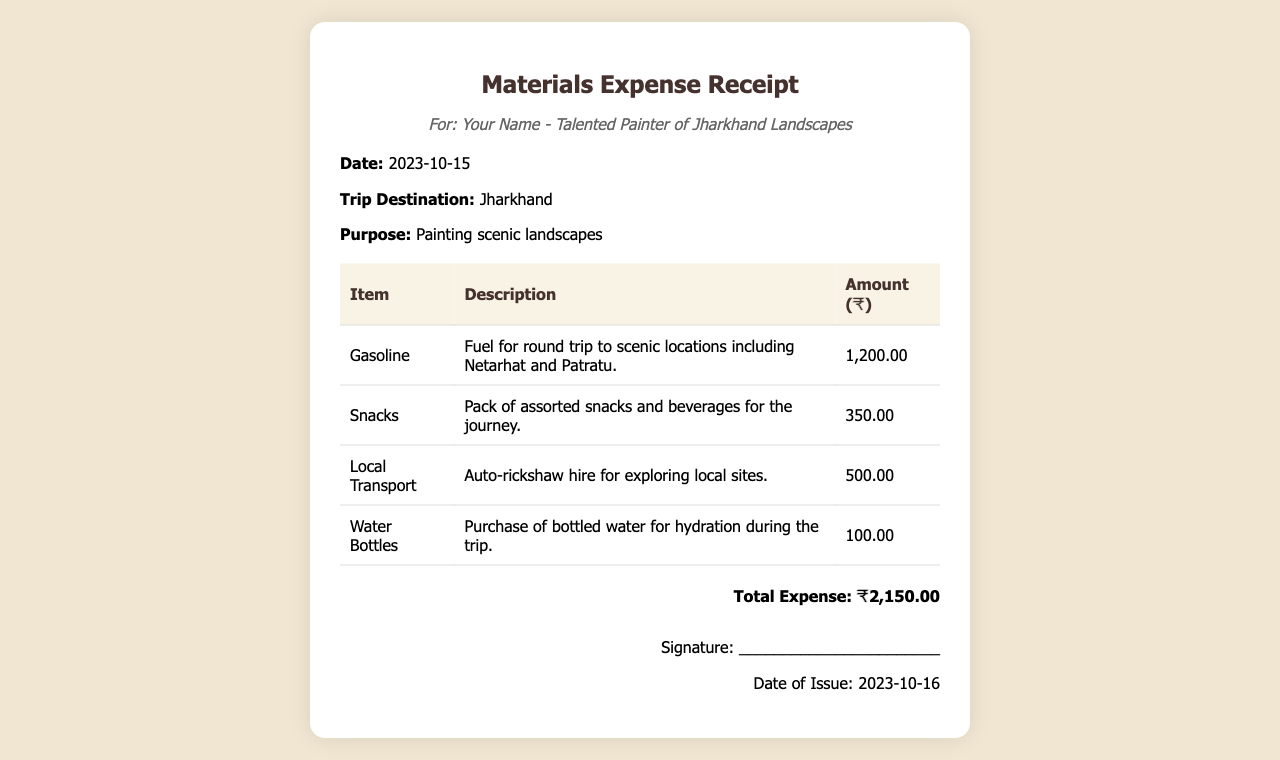What is the date of the trip? The date of the trip is specified in the document, which denotes when the expenses were incurred.
Answer: 2023-10-15 What is the total expense amount? The total expense amount is the sum of all individual expenses listed in the document.
Answer: ₹2,150.00 What is the purpose of the trip? The purpose of the trip, as stated in the document, indicates what the expenses are related to.
Answer: Painting scenic landscapes How much was spent on snacks? The amount spent on snacks is specified in the expenses table within the document.
Answer: ₹350.00 What item was hired for exploring local sites? The document mentions local transport that was hired to facilitate visiting different places during the trip.
Answer: Auto-rickshaw What is the date of issue for the receipt? The date of issue is provided at the bottom of the receipt, marking when the receipt was generated.
Answer: 2023-10-16 How much did the gasoline cost? The cost of gasoline is listed in the document under the expenses section.
Answer: ₹1,200.00 What is included in the description for water bottles? The document describes the purchase of water bottles, indicating their purpose for the trip.
Answer: Hydration during the trip What city did the trip take place in? The destination of the trip is noted in the document, indicating the location where the expenses were incurred.
Answer: Jharkhand 